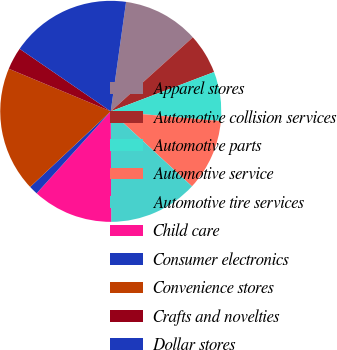Convert chart to OTSL. <chart><loc_0><loc_0><loc_500><loc_500><pie_chart><fcel>Apparel stores<fcel>Automotive collision services<fcel>Automotive parts<fcel>Automotive service<fcel>Automotive tire services<fcel>Child care<fcel>Consumer electronics<fcel>Convenience stores<fcel>Crafts and novelties<fcel>Dollar stores<nl><fcel>11.11%<fcel>5.89%<fcel>7.19%<fcel>10.46%<fcel>13.07%<fcel>11.76%<fcel>1.31%<fcel>18.29%<fcel>3.27%<fcel>17.64%<nl></chart> 